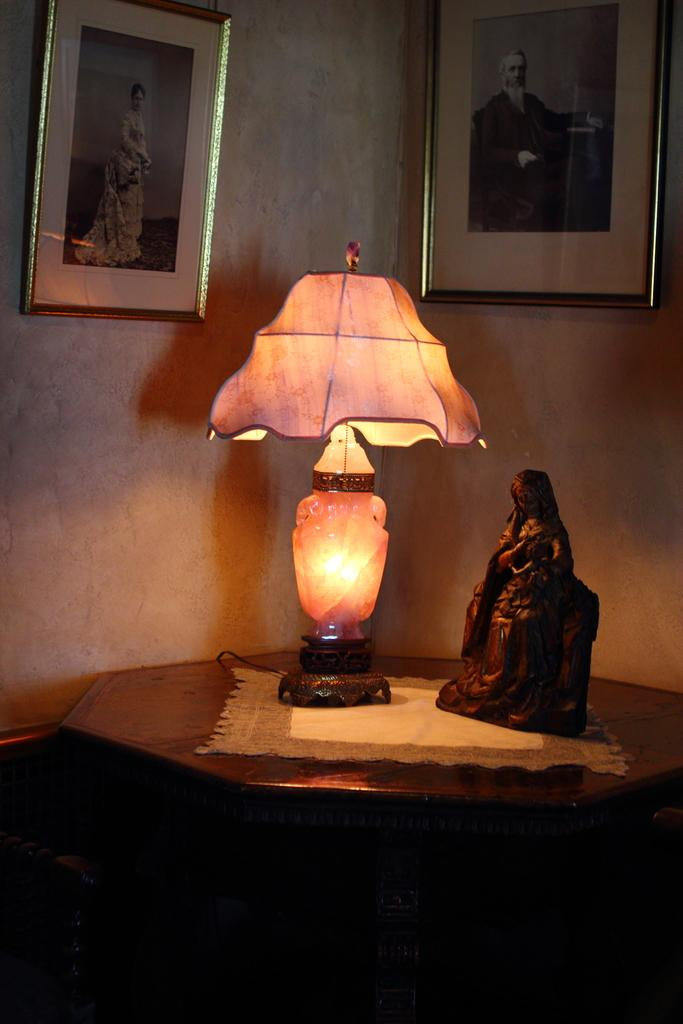What object is on the table in the image? There is a lamp on the table in the image. What is located next to the lamp on the table? There is a sculpture beside the lamp. What can be seen on the wall in the image? There are photo frames attached to the wall in the image. What type of yam is being played on the guitar in the image? There is no yam or guitar present in the image. 